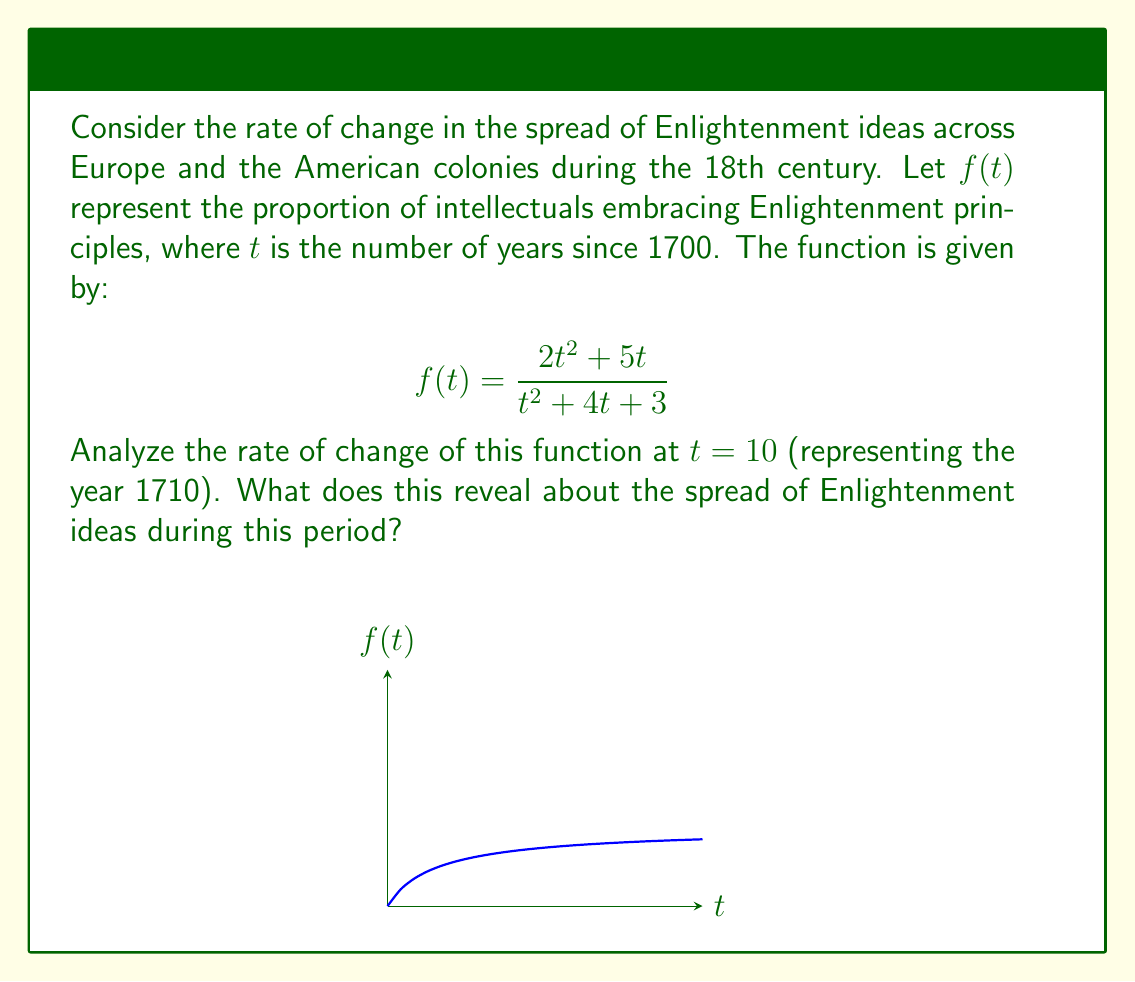Help me with this question. To analyze the rate of change, we need to find the derivative of $f(t)$ and evaluate it at $t = 10$. Let's approach this step-by-step:

1) First, we need to find $f'(t)$ using the quotient rule. Let $u = 2t^2 + 5t$ and $v = t^2 + 4t + 3$.

2) The quotient rule states: $\frac{d}{dt}\left(\frac{u}{v}\right) = \frac{v\frac{du}{dt} - u\frac{dv}{dt}}{v^2}$

3) Calculate $\frac{du}{dt}$ and $\frac{dv}{dt}$:
   $\frac{du}{dt} = 4t + 5$
   $\frac{dv}{dt} = 2t + 4$

4) Apply the quotient rule:

   $$f'(t) = \frac{(t^2 + 4t + 3)(4t + 5) - (2t^2 + 5t)(2t + 4)}{(t^2 + 4t + 3)^2}$$

5) Simplify the numerator:

   $$f'(t) = \frac{4t^3 + 16t^2 + 12t + 5t^2 + 20t + 15 - 4t^3 - 8t^2 - 10t^2 - 20t}{(t^2 + 4t + 3)^2}$$
   
   $$f'(t) = \frac{3t^2 + 12t + 15}{(t^2 + 4t + 3)^2}$$

6) Now, evaluate $f'(10)$:

   $$f'(10) = \frac{3(100) + 12(10) + 15}{(100 + 40 + 3)^2} = \frac{300 + 120 + 15}{143^2} = \frac{435}{20449} \approx 0.0213$$

7) Interpret the result: The rate of change at t = 10 (year 1710) is approximately 0.0213. This positive value indicates that the proportion of intellectuals embracing Enlightenment principles was increasing, albeit at a relatively slow rate.
Answer: $\frac{435}{20449} \approx 0.0213$, indicating a slow but positive growth in Enlightenment ideas in 1710. 